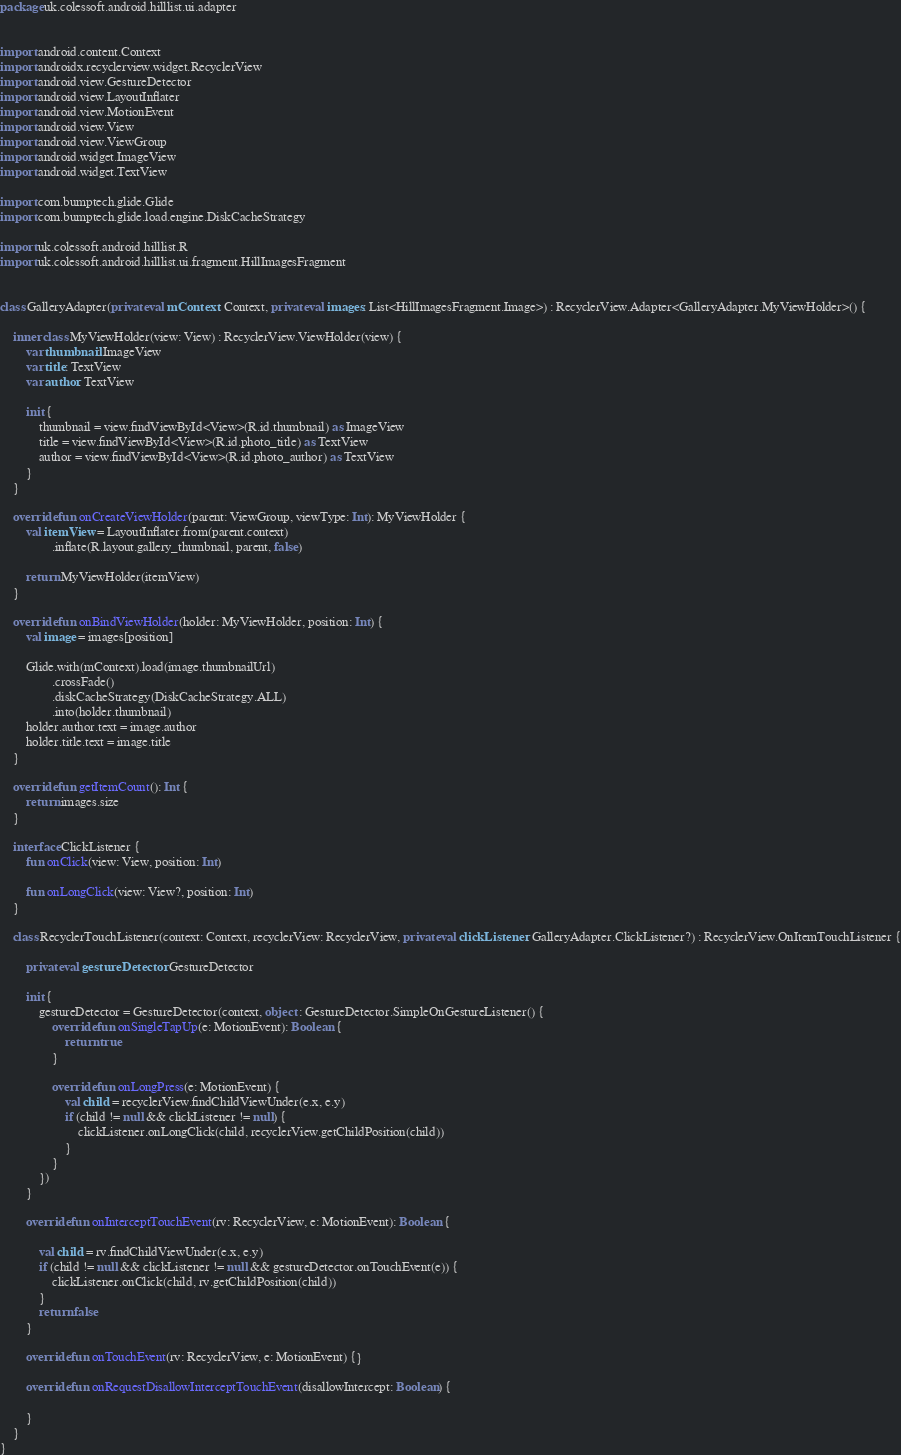<code> <loc_0><loc_0><loc_500><loc_500><_Kotlin_>package uk.colessoft.android.hilllist.ui.adapter


import android.content.Context
import androidx.recyclerview.widget.RecyclerView
import android.view.GestureDetector
import android.view.LayoutInflater
import android.view.MotionEvent
import android.view.View
import android.view.ViewGroup
import android.widget.ImageView
import android.widget.TextView

import com.bumptech.glide.Glide
import com.bumptech.glide.load.engine.DiskCacheStrategy

import uk.colessoft.android.hilllist.R
import uk.colessoft.android.hilllist.ui.fragment.HillImagesFragment


class GalleryAdapter(private val mContext: Context, private val images: List<HillImagesFragment.Image>) : RecyclerView.Adapter<GalleryAdapter.MyViewHolder>() {

    inner class MyViewHolder(view: View) : RecyclerView.ViewHolder(view) {
        var thumbnail: ImageView
        var title: TextView
        var author: TextView

        init {
            thumbnail = view.findViewById<View>(R.id.thumbnail) as ImageView
            title = view.findViewById<View>(R.id.photo_title) as TextView
            author = view.findViewById<View>(R.id.photo_author) as TextView
        }
    }

    override fun onCreateViewHolder(parent: ViewGroup, viewType: Int): MyViewHolder {
        val itemView = LayoutInflater.from(parent.context)
                .inflate(R.layout.gallery_thumbnail, parent, false)

        return MyViewHolder(itemView)
    }

    override fun onBindViewHolder(holder: MyViewHolder, position: Int) {
        val image = images[position]

        Glide.with(mContext).load(image.thumbnailUrl)
                .crossFade()
                .diskCacheStrategy(DiskCacheStrategy.ALL)
                .into(holder.thumbnail)
        holder.author.text = image.author
        holder.title.text = image.title
    }

    override fun getItemCount(): Int {
        return images.size
    }

    interface ClickListener {
        fun onClick(view: View, position: Int)

        fun onLongClick(view: View?, position: Int)
    }

    class RecyclerTouchListener(context: Context, recyclerView: RecyclerView, private val clickListener: GalleryAdapter.ClickListener?) : RecyclerView.OnItemTouchListener {

        private val gestureDetector: GestureDetector

        init {
            gestureDetector = GestureDetector(context, object : GestureDetector.SimpleOnGestureListener() {
                override fun onSingleTapUp(e: MotionEvent): Boolean {
                    return true
                }

                override fun onLongPress(e: MotionEvent) {
                    val child = recyclerView.findChildViewUnder(e.x, e.y)
                    if (child != null && clickListener != null) {
                        clickListener.onLongClick(child, recyclerView.getChildPosition(child))
                    }
                }
            })
        }

        override fun onInterceptTouchEvent(rv: RecyclerView, e: MotionEvent): Boolean {

            val child = rv.findChildViewUnder(e.x, e.y)
            if (child != null && clickListener != null && gestureDetector.onTouchEvent(e)) {
                clickListener.onClick(child, rv.getChildPosition(child))
            }
            return false
        }

        override fun onTouchEvent(rv: RecyclerView, e: MotionEvent) {}

        override fun onRequestDisallowInterceptTouchEvent(disallowIntercept: Boolean) {

        }
    }
}</code> 